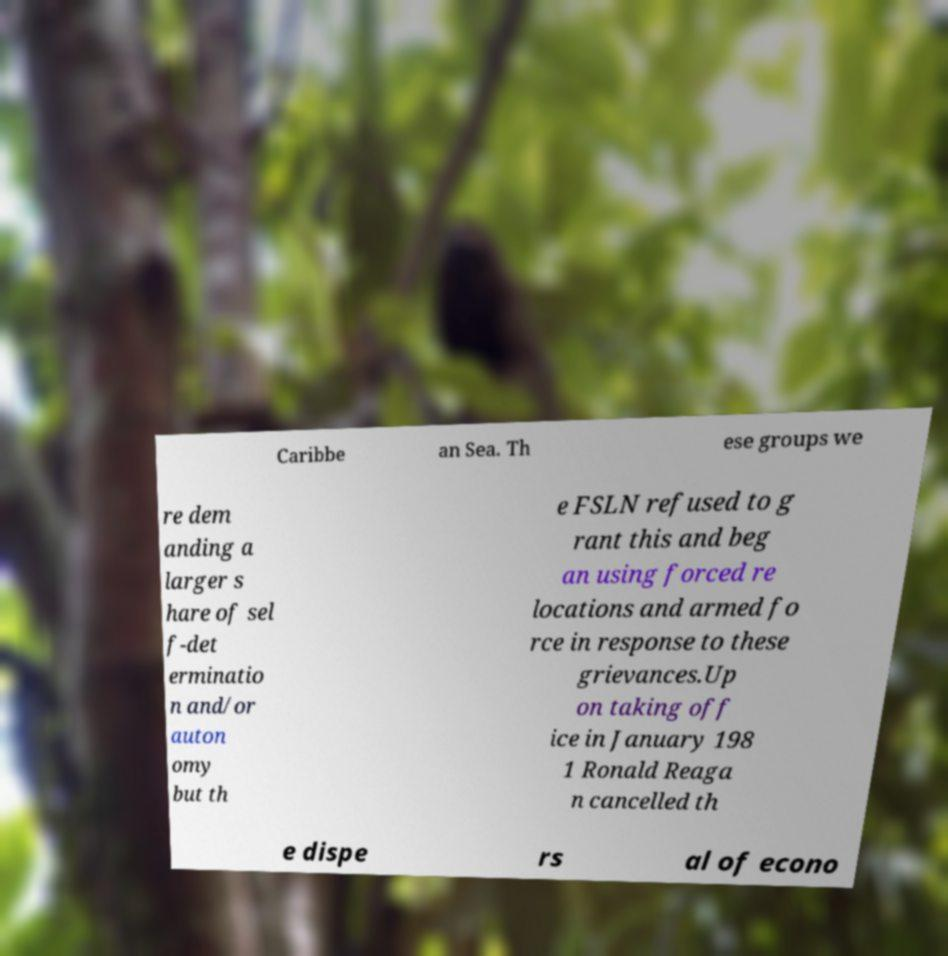For documentation purposes, I need the text within this image transcribed. Could you provide that? Caribbe an Sea. Th ese groups we re dem anding a larger s hare of sel f-det erminatio n and/or auton omy but th e FSLN refused to g rant this and beg an using forced re locations and armed fo rce in response to these grievances.Up on taking off ice in January 198 1 Ronald Reaga n cancelled th e dispe rs al of econo 